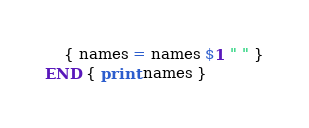Convert code to text. <code><loc_0><loc_0><loc_500><loc_500><_Awk_>    { names = names $1 " " }
END { print names }
</code> 